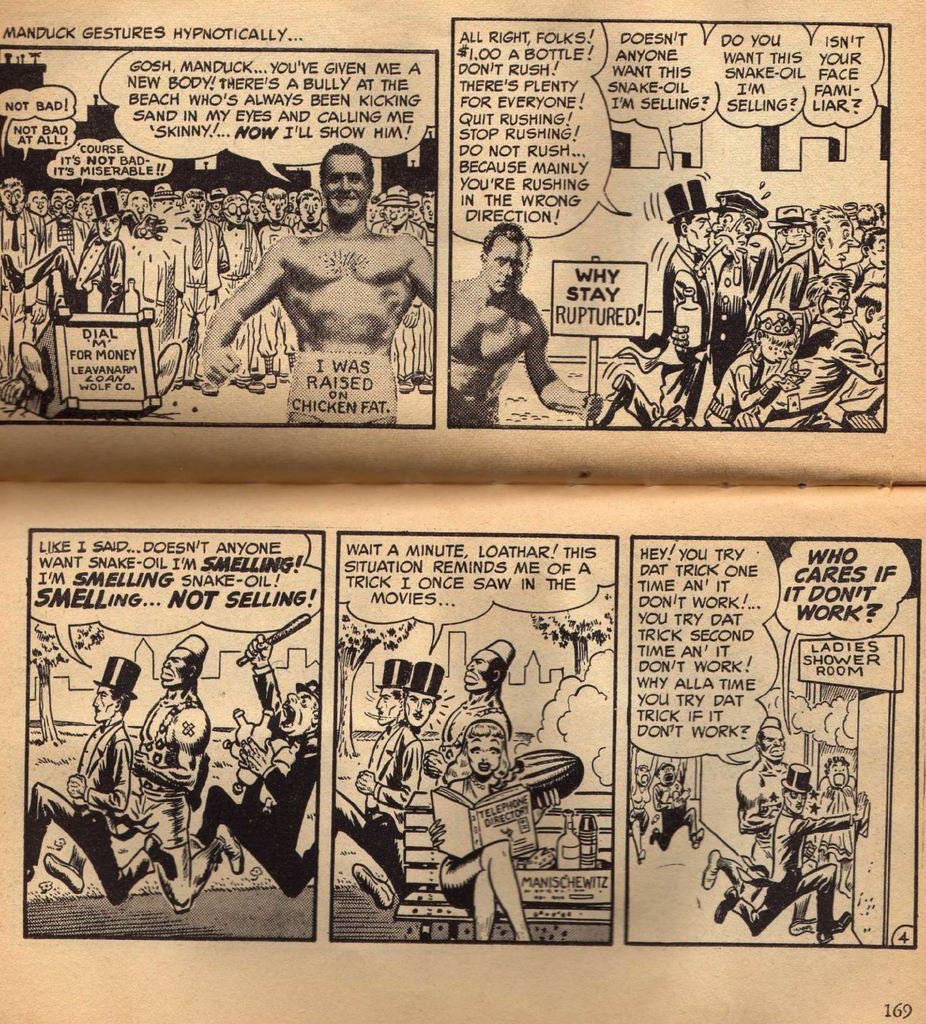<image>
Render a clear and concise summary of the photo. A page of comics is filled with words, two men are running into the ladies shower room in the last panel. 